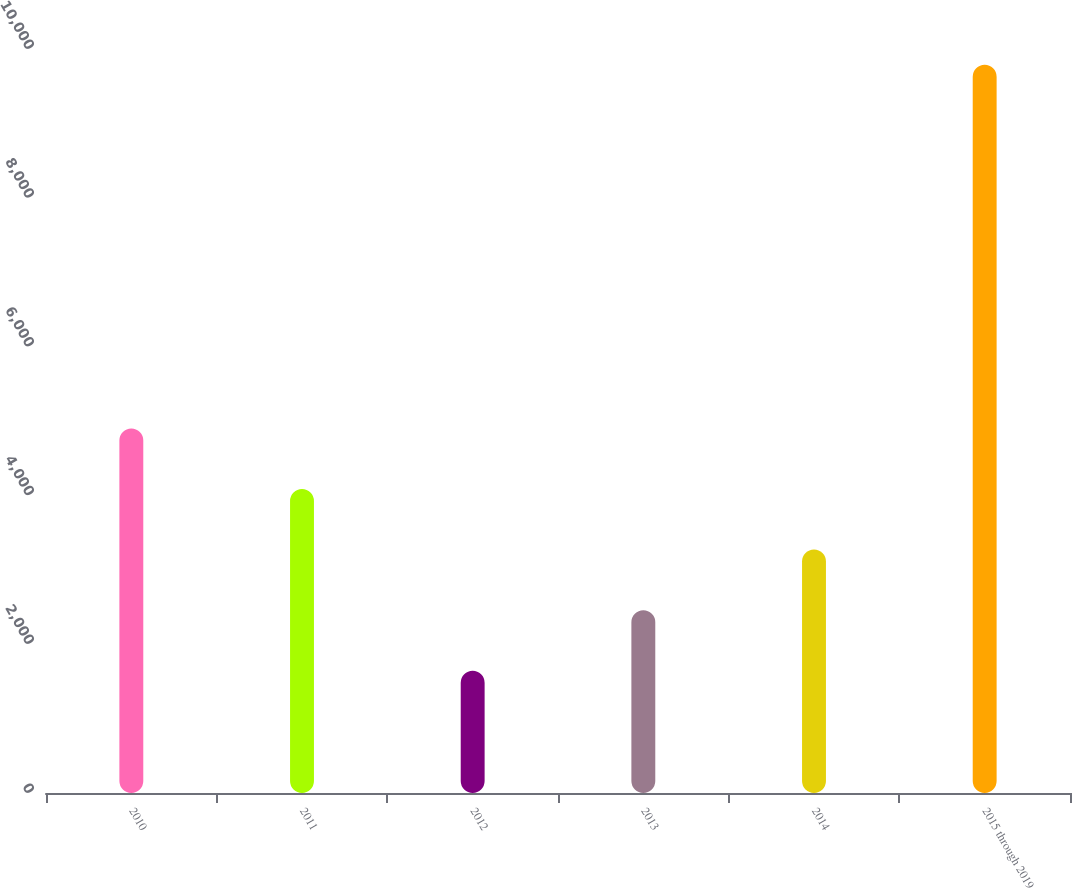<chart> <loc_0><loc_0><loc_500><loc_500><bar_chart><fcel>2010<fcel>2011<fcel>2012<fcel>2013<fcel>2014<fcel>2015 through 2019<nl><fcel>4900.8<fcel>4086.1<fcel>1642<fcel>2456.7<fcel>3271.4<fcel>9789<nl></chart> 